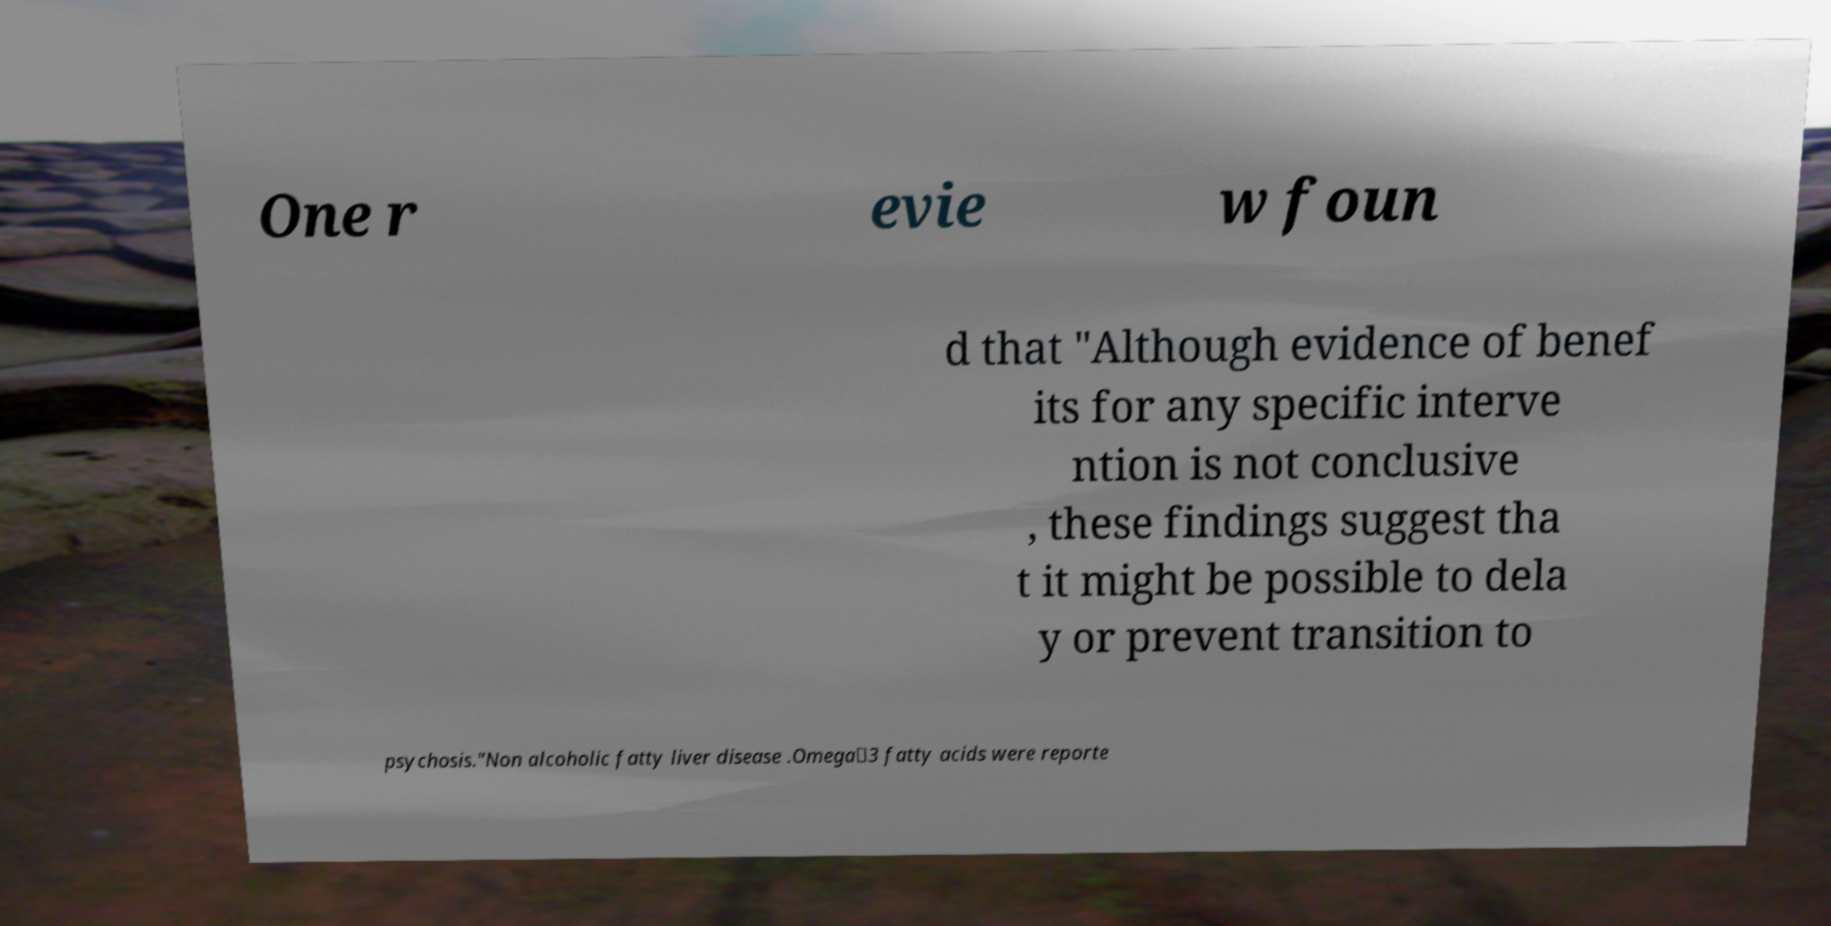There's text embedded in this image that I need extracted. Can you transcribe it verbatim? One r evie w foun d that "Although evidence of benef its for any specific interve ntion is not conclusive , these findings suggest tha t it might be possible to dela y or prevent transition to psychosis."Non alcoholic fatty liver disease .Omega‐3 fatty acids were reporte 